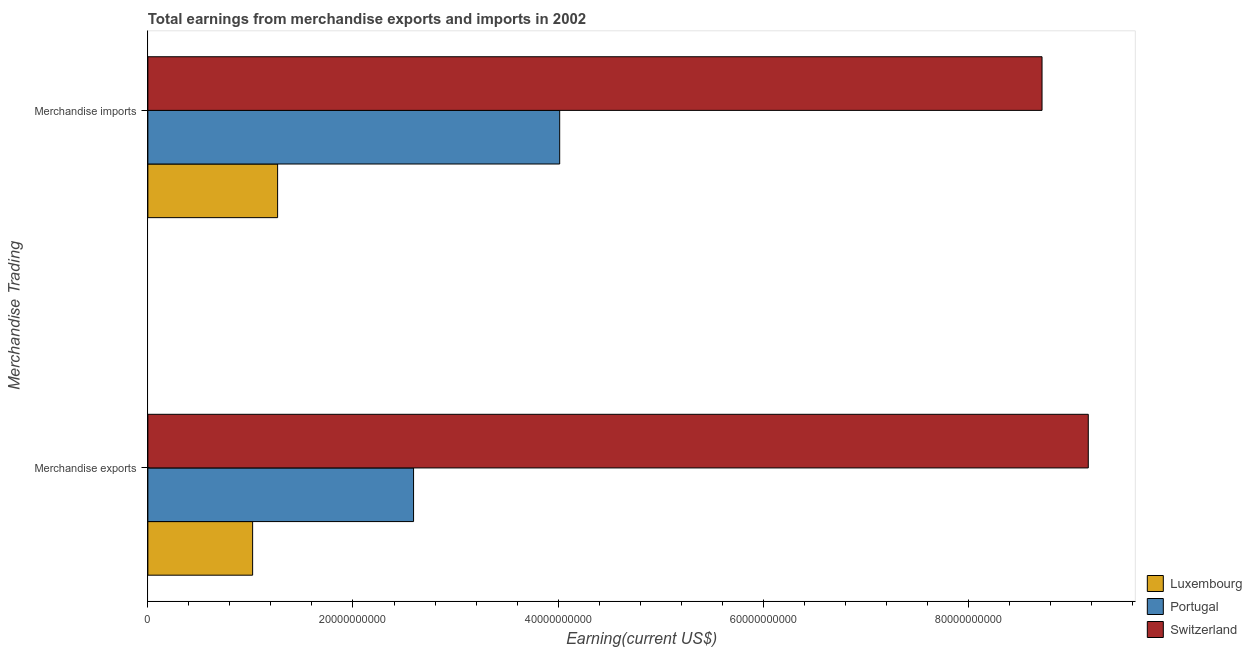How many different coloured bars are there?
Your answer should be very brief. 3. Are the number of bars per tick equal to the number of legend labels?
Ensure brevity in your answer.  Yes. Are the number of bars on each tick of the Y-axis equal?
Your answer should be compact. Yes. How many bars are there on the 2nd tick from the top?
Offer a very short reply. 3. What is the label of the 2nd group of bars from the top?
Your answer should be compact. Merchandise exports. What is the earnings from merchandise exports in Switzerland?
Your answer should be compact. 9.17e+1. Across all countries, what is the maximum earnings from merchandise imports?
Make the answer very short. 8.72e+1. Across all countries, what is the minimum earnings from merchandise exports?
Ensure brevity in your answer.  1.02e+1. In which country was the earnings from merchandise exports maximum?
Offer a very short reply. Switzerland. In which country was the earnings from merchandise exports minimum?
Your answer should be very brief. Luxembourg. What is the total earnings from merchandise imports in the graph?
Ensure brevity in your answer.  1.40e+11. What is the difference between the earnings from merchandise exports in Luxembourg and that in Switzerland?
Make the answer very short. -8.15e+1. What is the difference between the earnings from merchandise exports in Luxembourg and the earnings from merchandise imports in Portugal?
Provide a succinct answer. -2.99e+1. What is the average earnings from merchandise exports per country?
Keep it short and to the point. 4.26e+1. What is the difference between the earnings from merchandise imports and earnings from merchandise exports in Switzerland?
Offer a very short reply. -4.51e+09. What is the ratio of the earnings from merchandise imports in Switzerland to that in Luxembourg?
Give a very brief answer. 6.89. Is the earnings from merchandise imports in Portugal less than that in Switzerland?
Give a very brief answer. Yes. In how many countries, is the earnings from merchandise imports greater than the average earnings from merchandise imports taken over all countries?
Keep it short and to the point. 1. What does the 2nd bar from the top in Merchandise imports represents?
Your response must be concise. Portugal. What does the 3rd bar from the bottom in Merchandise exports represents?
Make the answer very short. Switzerland. How many bars are there?
Your answer should be compact. 6. Are all the bars in the graph horizontal?
Your answer should be very brief. Yes. Does the graph contain any zero values?
Make the answer very short. No. How many legend labels are there?
Ensure brevity in your answer.  3. What is the title of the graph?
Provide a succinct answer. Total earnings from merchandise exports and imports in 2002. Does "Tajikistan" appear as one of the legend labels in the graph?
Your answer should be compact. No. What is the label or title of the X-axis?
Provide a short and direct response. Earning(current US$). What is the label or title of the Y-axis?
Your answer should be very brief. Merchandise Trading. What is the Earning(current US$) of Luxembourg in Merchandise exports?
Offer a terse response. 1.02e+1. What is the Earning(current US$) in Portugal in Merchandise exports?
Offer a terse response. 2.59e+1. What is the Earning(current US$) in Switzerland in Merchandise exports?
Offer a terse response. 9.17e+1. What is the Earning(current US$) of Luxembourg in Merchandise imports?
Provide a succinct answer. 1.27e+1. What is the Earning(current US$) of Portugal in Merchandise imports?
Give a very brief answer. 4.02e+1. What is the Earning(current US$) of Switzerland in Merchandise imports?
Your answer should be compact. 8.72e+1. Across all Merchandise Trading, what is the maximum Earning(current US$) in Luxembourg?
Keep it short and to the point. 1.27e+1. Across all Merchandise Trading, what is the maximum Earning(current US$) of Portugal?
Offer a very short reply. 4.02e+1. Across all Merchandise Trading, what is the maximum Earning(current US$) in Switzerland?
Offer a very short reply. 9.17e+1. Across all Merchandise Trading, what is the minimum Earning(current US$) in Luxembourg?
Make the answer very short. 1.02e+1. Across all Merchandise Trading, what is the minimum Earning(current US$) in Portugal?
Ensure brevity in your answer.  2.59e+1. Across all Merchandise Trading, what is the minimum Earning(current US$) in Switzerland?
Provide a succinct answer. 8.72e+1. What is the total Earning(current US$) of Luxembourg in the graph?
Provide a short and direct response. 2.29e+1. What is the total Earning(current US$) in Portugal in the graph?
Make the answer very short. 6.61e+1. What is the total Earning(current US$) in Switzerland in the graph?
Your answer should be very brief. 1.79e+11. What is the difference between the Earning(current US$) of Luxembourg in Merchandise exports and that in Merchandise imports?
Keep it short and to the point. -2.44e+09. What is the difference between the Earning(current US$) in Portugal in Merchandise exports and that in Merchandise imports?
Keep it short and to the point. -1.42e+1. What is the difference between the Earning(current US$) of Switzerland in Merchandise exports and that in Merchandise imports?
Make the answer very short. 4.51e+09. What is the difference between the Earning(current US$) in Luxembourg in Merchandise exports and the Earning(current US$) in Portugal in Merchandise imports?
Your response must be concise. -2.99e+1. What is the difference between the Earning(current US$) of Luxembourg in Merchandise exports and the Earning(current US$) of Switzerland in Merchandise imports?
Ensure brevity in your answer.  -7.70e+1. What is the difference between the Earning(current US$) of Portugal in Merchandise exports and the Earning(current US$) of Switzerland in Merchandise imports?
Give a very brief answer. -6.13e+1. What is the average Earning(current US$) in Luxembourg per Merchandise Trading?
Your answer should be very brief. 1.14e+1. What is the average Earning(current US$) of Portugal per Merchandise Trading?
Your answer should be compact. 3.30e+1. What is the average Earning(current US$) in Switzerland per Merchandise Trading?
Provide a succinct answer. 8.94e+1. What is the difference between the Earning(current US$) of Luxembourg and Earning(current US$) of Portugal in Merchandise exports?
Your response must be concise. -1.57e+1. What is the difference between the Earning(current US$) of Luxembourg and Earning(current US$) of Switzerland in Merchandise exports?
Give a very brief answer. -8.15e+1. What is the difference between the Earning(current US$) in Portugal and Earning(current US$) in Switzerland in Merchandise exports?
Your answer should be very brief. -6.58e+1. What is the difference between the Earning(current US$) in Luxembourg and Earning(current US$) in Portugal in Merchandise imports?
Provide a short and direct response. -2.75e+1. What is the difference between the Earning(current US$) of Luxembourg and Earning(current US$) of Switzerland in Merchandise imports?
Provide a succinct answer. -7.45e+1. What is the difference between the Earning(current US$) in Portugal and Earning(current US$) in Switzerland in Merchandise imports?
Your answer should be very brief. -4.70e+1. What is the ratio of the Earning(current US$) of Luxembourg in Merchandise exports to that in Merchandise imports?
Keep it short and to the point. 0.81. What is the ratio of the Earning(current US$) in Portugal in Merchandise exports to that in Merchandise imports?
Provide a short and direct response. 0.65. What is the ratio of the Earning(current US$) in Switzerland in Merchandise exports to that in Merchandise imports?
Your answer should be very brief. 1.05. What is the difference between the highest and the second highest Earning(current US$) of Luxembourg?
Give a very brief answer. 2.44e+09. What is the difference between the highest and the second highest Earning(current US$) of Portugal?
Your answer should be compact. 1.42e+1. What is the difference between the highest and the second highest Earning(current US$) in Switzerland?
Make the answer very short. 4.51e+09. What is the difference between the highest and the lowest Earning(current US$) of Luxembourg?
Give a very brief answer. 2.44e+09. What is the difference between the highest and the lowest Earning(current US$) in Portugal?
Make the answer very short. 1.42e+1. What is the difference between the highest and the lowest Earning(current US$) in Switzerland?
Your answer should be very brief. 4.51e+09. 